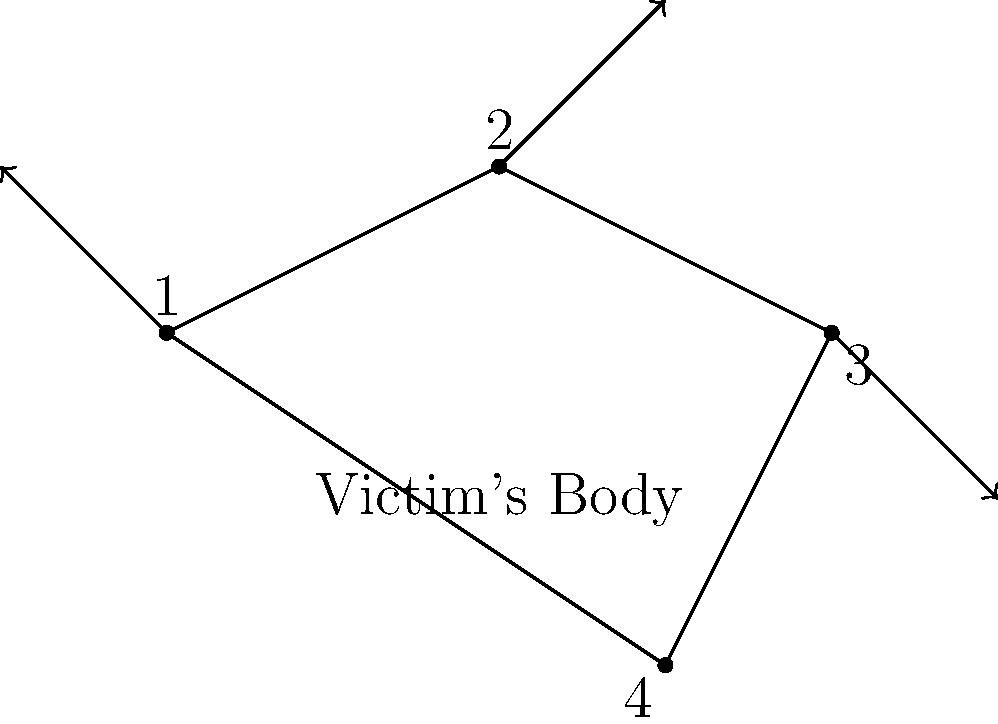Based on the injury pattern and force vectors shown in the diagram, what is the most likely sequence of events in this physical altercation? Assume the victim was initially standing upright. To reconstruct the sequence of events, we need to analyze the injury locations and force vectors:

1. Point 1: Located at the top of the head with an upward force vector. This suggests the first blow was to the head, possibly causing the victim to stumble backward.

2. Point 2: On the upper right side with a force vector pointing upward and to the right. This indicates a second blow, likely causing the victim to rotate and begin falling.

3. Point 3: On the lower right side with a downward force vector. This suggests the victim was falling or on the ground when this impact occurred.

4. Point 4: On the lower left side with no clear force vector. This could be from impact with the ground.

The biomechanical analysis suggests the following sequence:

a) The victim was hit on the head (Point 1), causing them to stumble backward.
b) A second blow to the upper right side (Point 2) caused rotation and initiated falling.
c) As the victim was falling or on the ground, they received another impact on the lower right side (Point 3).
d) The victim hit the ground, possibly causing the injury at Point 4.

This sequence is consistent with the injury pattern and the biomechanics of falling after successive impacts.
Answer: Head strike, upper body blow, falling impact, ground contact 